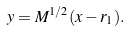Convert formula to latex. <formula><loc_0><loc_0><loc_500><loc_500>y = M ^ { 1 / 2 } ( x - r _ { 1 } ) .</formula> 